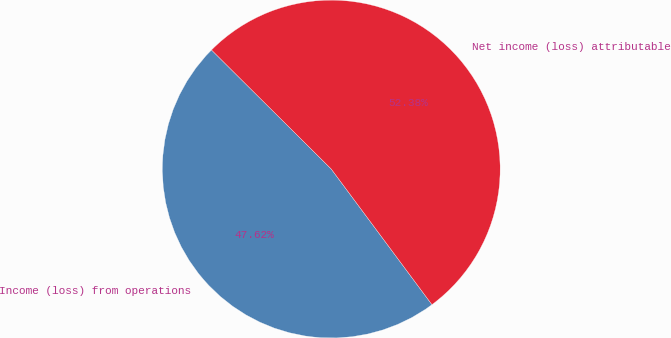<chart> <loc_0><loc_0><loc_500><loc_500><pie_chart><fcel>Income (loss) from operations<fcel>Net income (loss) attributable<nl><fcel>47.62%<fcel>52.38%<nl></chart> 